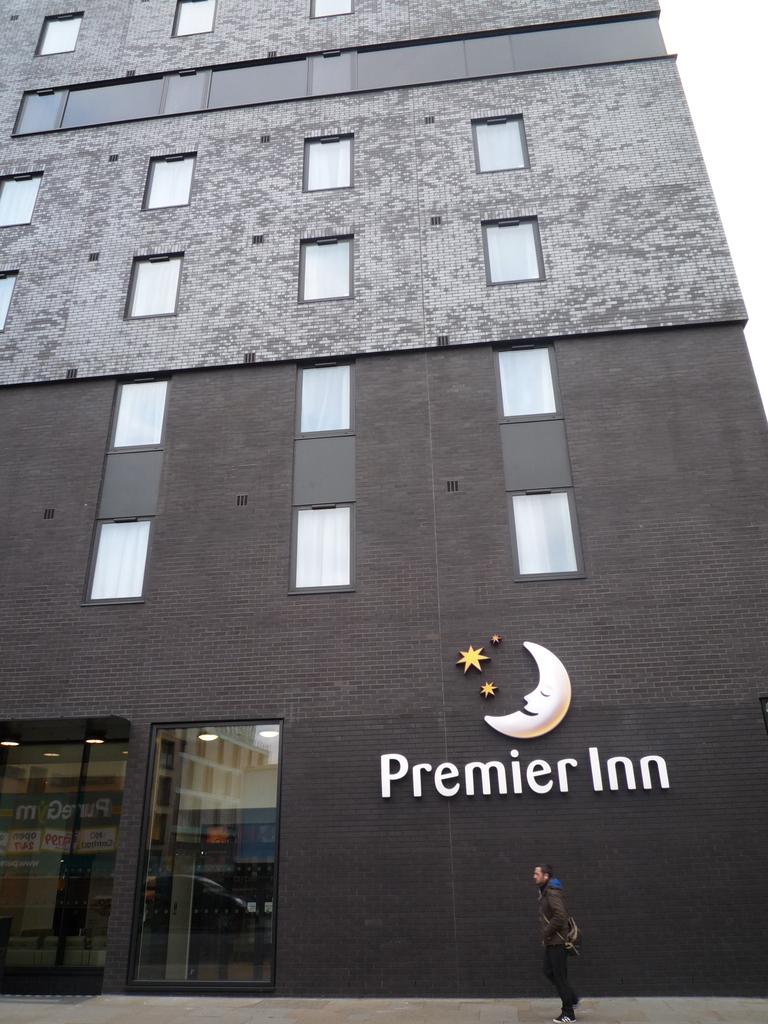What is this hotel?
Offer a terse response. Premier inn. 